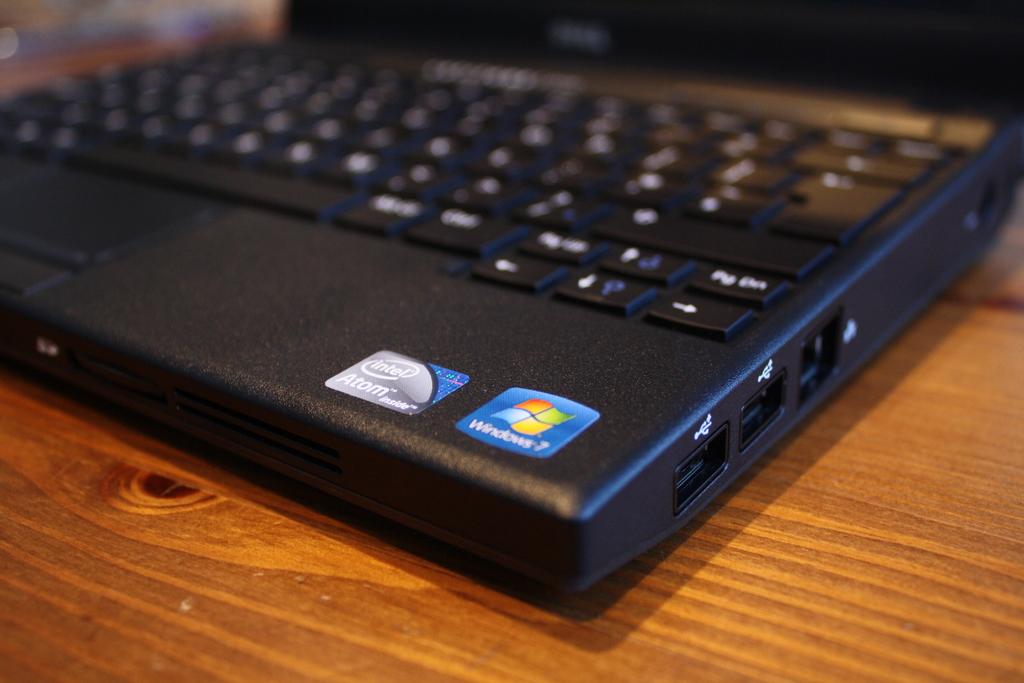Which version of windows is installed?
Give a very brief answer. 7. What brand of chip is in the computer?
Keep it short and to the point. Intel. 